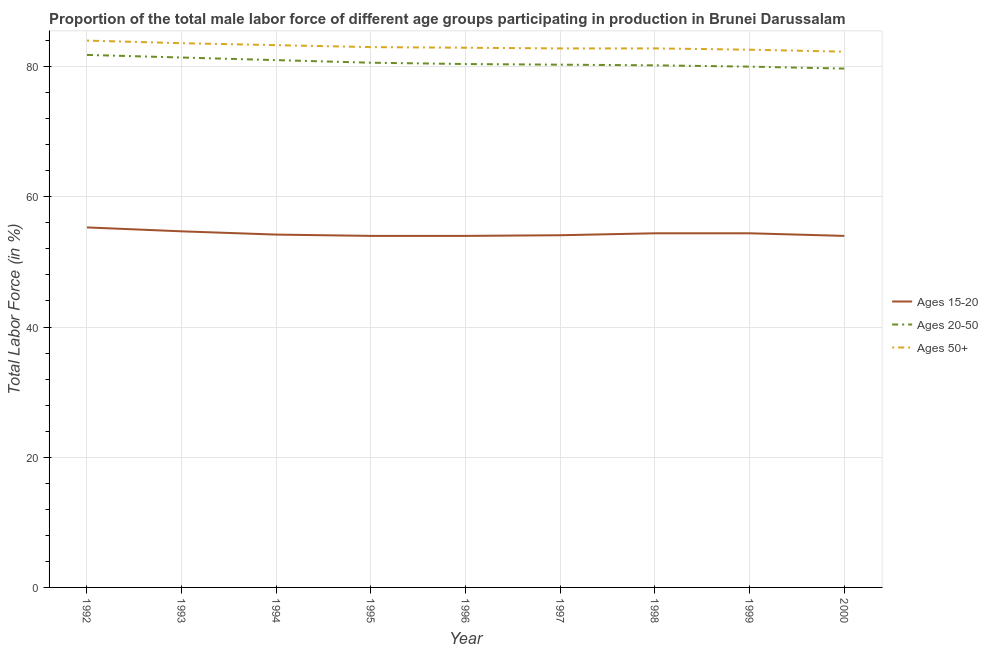Is the number of lines equal to the number of legend labels?
Offer a very short reply. Yes. Across all years, what is the maximum percentage of male labor force within the age group 20-50?
Provide a short and direct response. 81.8. Across all years, what is the minimum percentage of male labor force above age 50?
Your response must be concise. 82.3. In which year was the percentage of male labor force within the age group 15-20 maximum?
Provide a succinct answer. 1992. In which year was the percentage of male labor force within the age group 15-20 minimum?
Make the answer very short. 1995. What is the total percentage of male labor force within the age group 15-20 in the graph?
Ensure brevity in your answer.  489.1. What is the difference between the percentage of male labor force above age 50 in 1995 and that in 2000?
Ensure brevity in your answer.  0.7. What is the difference between the percentage of male labor force above age 50 in 1992 and the percentage of male labor force within the age group 15-20 in 1993?
Your answer should be compact. 29.3. What is the average percentage of male labor force above age 50 per year?
Your answer should be very brief. 83.03. In the year 2000, what is the difference between the percentage of male labor force above age 50 and percentage of male labor force within the age group 15-20?
Ensure brevity in your answer.  28.3. What is the ratio of the percentage of male labor force within the age group 20-50 in 1994 to that in 2000?
Make the answer very short. 1.02. What is the difference between the highest and the second highest percentage of male labor force above age 50?
Give a very brief answer. 0.4. What is the difference between the highest and the lowest percentage of male labor force within the age group 15-20?
Your answer should be very brief. 1.3. In how many years, is the percentage of male labor force above age 50 greater than the average percentage of male labor force above age 50 taken over all years?
Provide a short and direct response. 3. Is the sum of the percentage of male labor force above age 50 in 1998 and 1999 greater than the maximum percentage of male labor force within the age group 15-20 across all years?
Provide a succinct answer. Yes. Is it the case that in every year, the sum of the percentage of male labor force within the age group 15-20 and percentage of male labor force within the age group 20-50 is greater than the percentage of male labor force above age 50?
Make the answer very short. Yes. How many lines are there?
Your answer should be very brief. 3. How many years are there in the graph?
Give a very brief answer. 9. What is the difference between two consecutive major ticks on the Y-axis?
Your answer should be compact. 20. Are the values on the major ticks of Y-axis written in scientific E-notation?
Keep it short and to the point. No. Does the graph contain any zero values?
Provide a short and direct response. No. How many legend labels are there?
Offer a very short reply. 3. How are the legend labels stacked?
Ensure brevity in your answer.  Vertical. What is the title of the graph?
Offer a very short reply. Proportion of the total male labor force of different age groups participating in production in Brunei Darussalam. Does "Transport services" appear as one of the legend labels in the graph?
Provide a succinct answer. No. What is the label or title of the X-axis?
Provide a succinct answer. Year. What is the Total Labor Force (in %) in Ages 15-20 in 1992?
Your response must be concise. 55.3. What is the Total Labor Force (in %) in Ages 20-50 in 1992?
Offer a very short reply. 81.8. What is the Total Labor Force (in %) of Ages 15-20 in 1993?
Provide a short and direct response. 54.7. What is the Total Labor Force (in %) in Ages 20-50 in 1993?
Ensure brevity in your answer.  81.4. What is the Total Labor Force (in %) of Ages 50+ in 1993?
Provide a succinct answer. 83.6. What is the Total Labor Force (in %) of Ages 15-20 in 1994?
Your response must be concise. 54.2. What is the Total Labor Force (in %) of Ages 20-50 in 1994?
Provide a short and direct response. 81. What is the Total Labor Force (in %) in Ages 50+ in 1994?
Provide a succinct answer. 83.3. What is the Total Labor Force (in %) in Ages 20-50 in 1995?
Provide a short and direct response. 80.6. What is the Total Labor Force (in %) of Ages 20-50 in 1996?
Your answer should be compact. 80.4. What is the Total Labor Force (in %) of Ages 50+ in 1996?
Offer a very short reply. 82.9. What is the Total Labor Force (in %) in Ages 15-20 in 1997?
Keep it short and to the point. 54.1. What is the Total Labor Force (in %) of Ages 20-50 in 1997?
Offer a terse response. 80.3. What is the Total Labor Force (in %) of Ages 50+ in 1997?
Offer a very short reply. 82.8. What is the Total Labor Force (in %) of Ages 15-20 in 1998?
Make the answer very short. 54.4. What is the Total Labor Force (in %) of Ages 20-50 in 1998?
Ensure brevity in your answer.  80.2. What is the Total Labor Force (in %) in Ages 50+ in 1998?
Your answer should be very brief. 82.8. What is the Total Labor Force (in %) of Ages 15-20 in 1999?
Keep it short and to the point. 54.4. What is the Total Labor Force (in %) in Ages 20-50 in 1999?
Provide a short and direct response. 80. What is the Total Labor Force (in %) of Ages 50+ in 1999?
Your answer should be very brief. 82.6. What is the Total Labor Force (in %) in Ages 15-20 in 2000?
Provide a succinct answer. 54. What is the Total Labor Force (in %) in Ages 20-50 in 2000?
Offer a terse response. 79.7. What is the Total Labor Force (in %) of Ages 50+ in 2000?
Ensure brevity in your answer.  82.3. Across all years, what is the maximum Total Labor Force (in %) of Ages 15-20?
Give a very brief answer. 55.3. Across all years, what is the maximum Total Labor Force (in %) in Ages 20-50?
Your response must be concise. 81.8. Across all years, what is the minimum Total Labor Force (in %) of Ages 20-50?
Make the answer very short. 79.7. Across all years, what is the minimum Total Labor Force (in %) of Ages 50+?
Keep it short and to the point. 82.3. What is the total Total Labor Force (in %) in Ages 15-20 in the graph?
Offer a terse response. 489.1. What is the total Total Labor Force (in %) in Ages 20-50 in the graph?
Your answer should be very brief. 725.4. What is the total Total Labor Force (in %) of Ages 50+ in the graph?
Ensure brevity in your answer.  747.3. What is the difference between the Total Labor Force (in %) in Ages 15-20 in 1992 and that in 1994?
Offer a very short reply. 1.1. What is the difference between the Total Labor Force (in %) of Ages 20-50 in 1992 and that in 1994?
Your response must be concise. 0.8. What is the difference between the Total Labor Force (in %) in Ages 50+ in 1992 and that in 1995?
Provide a succinct answer. 1. What is the difference between the Total Labor Force (in %) of Ages 15-20 in 1992 and that in 1996?
Provide a succinct answer. 1.3. What is the difference between the Total Labor Force (in %) in Ages 50+ in 1992 and that in 1996?
Provide a succinct answer. 1.1. What is the difference between the Total Labor Force (in %) in Ages 15-20 in 1992 and that in 1997?
Provide a succinct answer. 1.2. What is the difference between the Total Labor Force (in %) of Ages 20-50 in 1992 and that in 1997?
Your answer should be very brief. 1.5. What is the difference between the Total Labor Force (in %) of Ages 50+ in 1992 and that in 1997?
Make the answer very short. 1.2. What is the difference between the Total Labor Force (in %) in Ages 20-50 in 1993 and that in 1994?
Your answer should be compact. 0.4. What is the difference between the Total Labor Force (in %) of Ages 50+ in 1993 and that in 1994?
Provide a succinct answer. 0.3. What is the difference between the Total Labor Force (in %) of Ages 15-20 in 1993 and that in 1995?
Your response must be concise. 0.7. What is the difference between the Total Labor Force (in %) of Ages 20-50 in 1993 and that in 1995?
Your answer should be very brief. 0.8. What is the difference between the Total Labor Force (in %) in Ages 15-20 in 1993 and that in 1996?
Provide a succinct answer. 0.7. What is the difference between the Total Labor Force (in %) in Ages 15-20 in 1993 and that in 1997?
Your response must be concise. 0.6. What is the difference between the Total Labor Force (in %) of Ages 15-20 in 1993 and that in 1998?
Keep it short and to the point. 0.3. What is the difference between the Total Labor Force (in %) of Ages 20-50 in 1993 and that in 1998?
Keep it short and to the point. 1.2. What is the difference between the Total Labor Force (in %) in Ages 50+ in 1993 and that in 1998?
Your answer should be very brief. 0.8. What is the difference between the Total Labor Force (in %) in Ages 50+ in 1993 and that in 1999?
Provide a short and direct response. 1. What is the difference between the Total Labor Force (in %) of Ages 15-20 in 1993 and that in 2000?
Keep it short and to the point. 0.7. What is the difference between the Total Labor Force (in %) in Ages 20-50 in 1993 and that in 2000?
Make the answer very short. 1.7. What is the difference between the Total Labor Force (in %) in Ages 15-20 in 1994 and that in 1995?
Provide a succinct answer. 0.2. What is the difference between the Total Labor Force (in %) of Ages 15-20 in 1994 and that in 1996?
Your response must be concise. 0.2. What is the difference between the Total Labor Force (in %) of Ages 50+ in 1994 and that in 1996?
Make the answer very short. 0.4. What is the difference between the Total Labor Force (in %) of Ages 20-50 in 1994 and that in 1997?
Offer a very short reply. 0.7. What is the difference between the Total Labor Force (in %) of Ages 50+ in 1994 and that in 1998?
Make the answer very short. 0.5. What is the difference between the Total Labor Force (in %) of Ages 15-20 in 1994 and that in 1999?
Your answer should be compact. -0.2. What is the difference between the Total Labor Force (in %) of Ages 20-50 in 1994 and that in 1999?
Your answer should be compact. 1. What is the difference between the Total Labor Force (in %) in Ages 20-50 in 1994 and that in 2000?
Offer a terse response. 1.3. What is the difference between the Total Labor Force (in %) in Ages 20-50 in 1995 and that in 1996?
Make the answer very short. 0.2. What is the difference between the Total Labor Force (in %) of Ages 50+ in 1995 and that in 1996?
Offer a very short reply. 0.1. What is the difference between the Total Labor Force (in %) of Ages 50+ in 1995 and that in 1997?
Give a very brief answer. 0.2. What is the difference between the Total Labor Force (in %) of Ages 15-20 in 1995 and that in 1998?
Give a very brief answer. -0.4. What is the difference between the Total Labor Force (in %) of Ages 50+ in 1995 and that in 1998?
Make the answer very short. 0.2. What is the difference between the Total Labor Force (in %) in Ages 50+ in 1995 and that in 1999?
Your answer should be compact. 0.4. What is the difference between the Total Labor Force (in %) of Ages 15-20 in 1995 and that in 2000?
Provide a short and direct response. 0. What is the difference between the Total Labor Force (in %) in Ages 20-50 in 1995 and that in 2000?
Your answer should be compact. 0.9. What is the difference between the Total Labor Force (in %) in Ages 50+ in 1995 and that in 2000?
Make the answer very short. 0.7. What is the difference between the Total Labor Force (in %) of Ages 20-50 in 1996 and that in 1998?
Offer a very short reply. 0.2. What is the difference between the Total Labor Force (in %) in Ages 50+ in 1996 and that in 1998?
Provide a succinct answer. 0.1. What is the difference between the Total Labor Force (in %) of Ages 15-20 in 1996 and that in 2000?
Your answer should be very brief. 0. What is the difference between the Total Labor Force (in %) in Ages 20-50 in 1996 and that in 2000?
Provide a succinct answer. 0.7. What is the difference between the Total Labor Force (in %) in Ages 50+ in 1997 and that in 1998?
Give a very brief answer. 0. What is the difference between the Total Labor Force (in %) in Ages 50+ in 1997 and that in 1999?
Provide a short and direct response. 0.2. What is the difference between the Total Labor Force (in %) of Ages 50+ in 1997 and that in 2000?
Offer a terse response. 0.5. What is the difference between the Total Labor Force (in %) of Ages 15-20 in 1998 and that in 2000?
Offer a very short reply. 0.4. What is the difference between the Total Labor Force (in %) of Ages 50+ in 1998 and that in 2000?
Your answer should be very brief. 0.5. What is the difference between the Total Labor Force (in %) in Ages 15-20 in 1999 and that in 2000?
Offer a very short reply. 0.4. What is the difference between the Total Labor Force (in %) of Ages 20-50 in 1999 and that in 2000?
Your response must be concise. 0.3. What is the difference between the Total Labor Force (in %) of Ages 15-20 in 1992 and the Total Labor Force (in %) of Ages 20-50 in 1993?
Provide a succinct answer. -26.1. What is the difference between the Total Labor Force (in %) of Ages 15-20 in 1992 and the Total Labor Force (in %) of Ages 50+ in 1993?
Ensure brevity in your answer.  -28.3. What is the difference between the Total Labor Force (in %) in Ages 20-50 in 1992 and the Total Labor Force (in %) in Ages 50+ in 1993?
Make the answer very short. -1.8. What is the difference between the Total Labor Force (in %) in Ages 15-20 in 1992 and the Total Labor Force (in %) in Ages 20-50 in 1994?
Provide a succinct answer. -25.7. What is the difference between the Total Labor Force (in %) of Ages 15-20 in 1992 and the Total Labor Force (in %) of Ages 20-50 in 1995?
Your answer should be compact. -25.3. What is the difference between the Total Labor Force (in %) of Ages 15-20 in 1992 and the Total Labor Force (in %) of Ages 50+ in 1995?
Make the answer very short. -27.7. What is the difference between the Total Labor Force (in %) of Ages 20-50 in 1992 and the Total Labor Force (in %) of Ages 50+ in 1995?
Make the answer very short. -1.2. What is the difference between the Total Labor Force (in %) in Ages 15-20 in 1992 and the Total Labor Force (in %) in Ages 20-50 in 1996?
Give a very brief answer. -25.1. What is the difference between the Total Labor Force (in %) in Ages 15-20 in 1992 and the Total Labor Force (in %) in Ages 50+ in 1996?
Keep it short and to the point. -27.6. What is the difference between the Total Labor Force (in %) of Ages 20-50 in 1992 and the Total Labor Force (in %) of Ages 50+ in 1996?
Give a very brief answer. -1.1. What is the difference between the Total Labor Force (in %) of Ages 15-20 in 1992 and the Total Labor Force (in %) of Ages 50+ in 1997?
Ensure brevity in your answer.  -27.5. What is the difference between the Total Labor Force (in %) in Ages 20-50 in 1992 and the Total Labor Force (in %) in Ages 50+ in 1997?
Make the answer very short. -1. What is the difference between the Total Labor Force (in %) of Ages 15-20 in 1992 and the Total Labor Force (in %) of Ages 20-50 in 1998?
Your response must be concise. -24.9. What is the difference between the Total Labor Force (in %) of Ages 15-20 in 1992 and the Total Labor Force (in %) of Ages 50+ in 1998?
Offer a very short reply. -27.5. What is the difference between the Total Labor Force (in %) in Ages 20-50 in 1992 and the Total Labor Force (in %) in Ages 50+ in 1998?
Make the answer very short. -1. What is the difference between the Total Labor Force (in %) of Ages 15-20 in 1992 and the Total Labor Force (in %) of Ages 20-50 in 1999?
Your response must be concise. -24.7. What is the difference between the Total Labor Force (in %) in Ages 15-20 in 1992 and the Total Labor Force (in %) in Ages 50+ in 1999?
Provide a short and direct response. -27.3. What is the difference between the Total Labor Force (in %) in Ages 15-20 in 1992 and the Total Labor Force (in %) in Ages 20-50 in 2000?
Give a very brief answer. -24.4. What is the difference between the Total Labor Force (in %) in Ages 15-20 in 1992 and the Total Labor Force (in %) in Ages 50+ in 2000?
Make the answer very short. -27. What is the difference between the Total Labor Force (in %) of Ages 20-50 in 1992 and the Total Labor Force (in %) of Ages 50+ in 2000?
Give a very brief answer. -0.5. What is the difference between the Total Labor Force (in %) in Ages 15-20 in 1993 and the Total Labor Force (in %) in Ages 20-50 in 1994?
Your answer should be very brief. -26.3. What is the difference between the Total Labor Force (in %) of Ages 15-20 in 1993 and the Total Labor Force (in %) of Ages 50+ in 1994?
Provide a succinct answer. -28.6. What is the difference between the Total Labor Force (in %) in Ages 15-20 in 1993 and the Total Labor Force (in %) in Ages 20-50 in 1995?
Your response must be concise. -25.9. What is the difference between the Total Labor Force (in %) in Ages 15-20 in 1993 and the Total Labor Force (in %) in Ages 50+ in 1995?
Give a very brief answer. -28.3. What is the difference between the Total Labor Force (in %) of Ages 15-20 in 1993 and the Total Labor Force (in %) of Ages 20-50 in 1996?
Your answer should be compact. -25.7. What is the difference between the Total Labor Force (in %) in Ages 15-20 in 1993 and the Total Labor Force (in %) in Ages 50+ in 1996?
Your answer should be compact. -28.2. What is the difference between the Total Labor Force (in %) in Ages 20-50 in 1993 and the Total Labor Force (in %) in Ages 50+ in 1996?
Keep it short and to the point. -1.5. What is the difference between the Total Labor Force (in %) in Ages 15-20 in 1993 and the Total Labor Force (in %) in Ages 20-50 in 1997?
Your answer should be very brief. -25.6. What is the difference between the Total Labor Force (in %) in Ages 15-20 in 1993 and the Total Labor Force (in %) in Ages 50+ in 1997?
Your answer should be very brief. -28.1. What is the difference between the Total Labor Force (in %) of Ages 20-50 in 1993 and the Total Labor Force (in %) of Ages 50+ in 1997?
Your response must be concise. -1.4. What is the difference between the Total Labor Force (in %) of Ages 15-20 in 1993 and the Total Labor Force (in %) of Ages 20-50 in 1998?
Your answer should be compact. -25.5. What is the difference between the Total Labor Force (in %) of Ages 15-20 in 1993 and the Total Labor Force (in %) of Ages 50+ in 1998?
Make the answer very short. -28.1. What is the difference between the Total Labor Force (in %) of Ages 15-20 in 1993 and the Total Labor Force (in %) of Ages 20-50 in 1999?
Offer a terse response. -25.3. What is the difference between the Total Labor Force (in %) in Ages 15-20 in 1993 and the Total Labor Force (in %) in Ages 50+ in 1999?
Give a very brief answer. -27.9. What is the difference between the Total Labor Force (in %) in Ages 20-50 in 1993 and the Total Labor Force (in %) in Ages 50+ in 1999?
Your answer should be compact. -1.2. What is the difference between the Total Labor Force (in %) in Ages 15-20 in 1993 and the Total Labor Force (in %) in Ages 20-50 in 2000?
Give a very brief answer. -25. What is the difference between the Total Labor Force (in %) of Ages 15-20 in 1993 and the Total Labor Force (in %) of Ages 50+ in 2000?
Provide a succinct answer. -27.6. What is the difference between the Total Labor Force (in %) of Ages 20-50 in 1993 and the Total Labor Force (in %) of Ages 50+ in 2000?
Offer a very short reply. -0.9. What is the difference between the Total Labor Force (in %) in Ages 15-20 in 1994 and the Total Labor Force (in %) in Ages 20-50 in 1995?
Your answer should be very brief. -26.4. What is the difference between the Total Labor Force (in %) in Ages 15-20 in 1994 and the Total Labor Force (in %) in Ages 50+ in 1995?
Your answer should be compact. -28.8. What is the difference between the Total Labor Force (in %) of Ages 15-20 in 1994 and the Total Labor Force (in %) of Ages 20-50 in 1996?
Your answer should be very brief. -26.2. What is the difference between the Total Labor Force (in %) of Ages 15-20 in 1994 and the Total Labor Force (in %) of Ages 50+ in 1996?
Make the answer very short. -28.7. What is the difference between the Total Labor Force (in %) in Ages 15-20 in 1994 and the Total Labor Force (in %) in Ages 20-50 in 1997?
Offer a very short reply. -26.1. What is the difference between the Total Labor Force (in %) in Ages 15-20 in 1994 and the Total Labor Force (in %) in Ages 50+ in 1997?
Offer a very short reply. -28.6. What is the difference between the Total Labor Force (in %) in Ages 15-20 in 1994 and the Total Labor Force (in %) in Ages 20-50 in 1998?
Keep it short and to the point. -26. What is the difference between the Total Labor Force (in %) of Ages 15-20 in 1994 and the Total Labor Force (in %) of Ages 50+ in 1998?
Your answer should be compact. -28.6. What is the difference between the Total Labor Force (in %) in Ages 15-20 in 1994 and the Total Labor Force (in %) in Ages 20-50 in 1999?
Your answer should be very brief. -25.8. What is the difference between the Total Labor Force (in %) in Ages 15-20 in 1994 and the Total Labor Force (in %) in Ages 50+ in 1999?
Keep it short and to the point. -28.4. What is the difference between the Total Labor Force (in %) in Ages 15-20 in 1994 and the Total Labor Force (in %) in Ages 20-50 in 2000?
Make the answer very short. -25.5. What is the difference between the Total Labor Force (in %) in Ages 15-20 in 1994 and the Total Labor Force (in %) in Ages 50+ in 2000?
Provide a succinct answer. -28.1. What is the difference between the Total Labor Force (in %) of Ages 20-50 in 1994 and the Total Labor Force (in %) of Ages 50+ in 2000?
Give a very brief answer. -1.3. What is the difference between the Total Labor Force (in %) of Ages 15-20 in 1995 and the Total Labor Force (in %) of Ages 20-50 in 1996?
Your answer should be compact. -26.4. What is the difference between the Total Labor Force (in %) of Ages 15-20 in 1995 and the Total Labor Force (in %) of Ages 50+ in 1996?
Your answer should be compact. -28.9. What is the difference between the Total Labor Force (in %) in Ages 15-20 in 1995 and the Total Labor Force (in %) in Ages 20-50 in 1997?
Provide a short and direct response. -26.3. What is the difference between the Total Labor Force (in %) of Ages 15-20 in 1995 and the Total Labor Force (in %) of Ages 50+ in 1997?
Give a very brief answer. -28.8. What is the difference between the Total Labor Force (in %) in Ages 20-50 in 1995 and the Total Labor Force (in %) in Ages 50+ in 1997?
Ensure brevity in your answer.  -2.2. What is the difference between the Total Labor Force (in %) in Ages 15-20 in 1995 and the Total Labor Force (in %) in Ages 20-50 in 1998?
Provide a succinct answer. -26.2. What is the difference between the Total Labor Force (in %) in Ages 15-20 in 1995 and the Total Labor Force (in %) in Ages 50+ in 1998?
Offer a terse response. -28.8. What is the difference between the Total Labor Force (in %) of Ages 20-50 in 1995 and the Total Labor Force (in %) of Ages 50+ in 1998?
Ensure brevity in your answer.  -2.2. What is the difference between the Total Labor Force (in %) in Ages 15-20 in 1995 and the Total Labor Force (in %) in Ages 20-50 in 1999?
Offer a terse response. -26. What is the difference between the Total Labor Force (in %) of Ages 15-20 in 1995 and the Total Labor Force (in %) of Ages 50+ in 1999?
Your answer should be compact. -28.6. What is the difference between the Total Labor Force (in %) in Ages 15-20 in 1995 and the Total Labor Force (in %) in Ages 20-50 in 2000?
Provide a succinct answer. -25.7. What is the difference between the Total Labor Force (in %) of Ages 15-20 in 1995 and the Total Labor Force (in %) of Ages 50+ in 2000?
Offer a terse response. -28.3. What is the difference between the Total Labor Force (in %) in Ages 15-20 in 1996 and the Total Labor Force (in %) in Ages 20-50 in 1997?
Your response must be concise. -26.3. What is the difference between the Total Labor Force (in %) in Ages 15-20 in 1996 and the Total Labor Force (in %) in Ages 50+ in 1997?
Offer a very short reply. -28.8. What is the difference between the Total Labor Force (in %) of Ages 15-20 in 1996 and the Total Labor Force (in %) of Ages 20-50 in 1998?
Give a very brief answer. -26.2. What is the difference between the Total Labor Force (in %) in Ages 15-20 in 1996 and the Total Labor Force (in %) in Ages 50+ in 1998?
Provide a succinct answer. -28.8. What is the difference between the Total Labor Force (in %) in Ages 15-20 in 1996 and the Total Labor Force (in %) in Ages 20-50 in 1999?
Your answer should be compact. -26. What is the difference between the Total Labor Force (in %) of Ages 15-20 in 1996 and the Total Labor Force (in %) of Ages 50+ in 1999?
Make the answer very short. -28.6. What is the difference between the Total Labor Force (in %) in Ages 20-50 in 1996 and the Total Labor Force (in %) in Ages 50+ in 1999?
Offer a terse response. -2.2. What is the difference between the Total Labor Force (in %) of Ages 15-20 in 1996 and the Total Labor Force (in %) of Ages 20-50 in 2000?
Offer a terse response. -25.7. What is the difference between the Total Labor Force (in %) in Ages 15-20 in 1996 and the Total Labor Force (in %) in Ages 50+ in 2000?
Offer a terse response. -28.3. What is the difference between the Total Labor Force (in %) in Ages 20-50 in 1996 and the Total Labor Force (in %) in Ages 50+ in 2000?
Offer a terse response. -1.9. What is the difference between the Total Labor Force (in %) of Ages 15-20 in 1997 and the Total Labor Force (in %) of Ages 20-50 in 1998?
Make the answer very short. -26.1. What is the difference between the Total Labor Force (in %) in Ages 15-20 in 1997 and the Total Labor Force (in %) in Ages 50+ in 1998?
Give a very brief answer. -28.7. What is the difference between the Total Labor Force (in %) of Ages 15-20 in 1997 and the Total Labor Force (in %) of Ages 20-50 in 1999?
Your answer should be compact. -25.9. What is the difference between the Total Labor Force (in %) of Ages 15-20 in 1997 and the Total Labor Force (in %) of Ages 50+ in 1999?
Keep it short and to the point. -28.5. What is the difference between the Total Labor Force (in %) of Ages 15-20 in 1997 and the Total Labor Force (in %) of Ages 20-50 in 2000?
Your answer should be compact. -25.6. What is the difference between the Total Labor Force (in %) in Ages 15-20 in 1997 and the Total Labor Force (in %) in Ages 50+ in 2000?
Offer a terse response. -28.2. What is the difference between the Total Labor Force (in %) in Ages 15-20 in 1998 and the Total Labor Force (in %) in Ages 20-50 in 1999?
Offer a terse response. -25.6. What is the difference between the Total Labor Force (in %) of Ages 15-20 in 1998 and the Total Labor Force (in %) of Ages 50+ in 1999?
Your answer should be compact. -28.2. What is the difference between the Total Labor Force (in %) in Ages 20-50 in 1998 and the Total Labor Force (in %) in Ages 50+ in 1999?
Your answer should be compact. -2.4. What is the difference between the Total Labor Force (in %) in Ages 15-20 in 1998 and the Total Labor Force (in %) in Ages 20-50 in 2000?
Make the answer very short. -25.3. What is the difference between the Total Labor Force (in %) of Ages 15-20 in 1998 and the Total Labor Force (in %) of Ages 50+ in 2000?
Give a very brief answer. -27.9. What is the difference between the Total Labor Force (in %) in Ages 15-20 in 1999 and the Total Labor Force (in %) in Ages 20-50 in 2000?
Your answer should be very brief. -25.3. What is the difference between the Total Labor Force (in %) of Ages 15-20 in 1999 and the Total Labor Force (in %) of Ages 50+ in 2000?
Provide a succinct answer. -27.9. What is the difference between the Total Labor Force (in %) of Ages 20-50 in 1999 and the Total Labor Force (in %) of Ages 50+ in 2000?
Your response must be concise. -2.3. What is the average Total Labor Force (in %) in Ages 15-20 per year?
Make the answer very short. 54.34. What is the average Total Labor Force (in %) in Ages 20-50 per year?
Your response must be concise. 80.6. What is the average Total Labor Force (in %) of Ages 50+ per year?
Give a very brief answer. 83.03. In the year 1992, what is the difference between the Total Labor Force (in %) of Ages 15-20 and Total Labor Force (in %) of Ages 20-50?
Your response must be concise. -26.5. In the year 1992, what is the difference between the Total Labor Force (in %) in Ages 15-20 and Total Labor Force (in %) in Ages 50+?
Provide a succinct answer. -28.7. In the year 1993, what is the difference between the Total Labor Force (in %) of Ages 15-20 and Total Labor Force (in %) of Ages 20-50?
Keep it short and to the point. -26.7. In the year 1993, what is the difference between the Total Labor Force (in %) of Ages 15-20 and Total Labor Force (in %) of Ages 50+?
Ensure brevity in your answer.  -28.9. In the year 1994, what is the difference between the Total Labor Force (in %) in Ages 15-20 and Total Labor Force (in %) in Ages 20-50?
Offer a very short reply. -26.8. In the year 1994, what is the difference between the Total Labor Force (in %) of Ages 15-20 and Total Labor Force (in %) of Ages 50+?
Offer a very short reply. -29.1. In the year 1995, what is the difference between the Total Labor Force (in %) in Ages 15-20 and Total Labor Force (in %) in Ages 20-50?
Keep it short and to the point. -26.6. In the year 1995, what is the difference between the Total Labor Force (in %) in Ages 15-20 and Total Labor Force (in %) in Ages 50+?
Give a very brief answer. -29. In the year 1996, what is the difference between the Total Labor Force (in %) of Ages 15-20 and Total Labor Force (in %) of Ages 20-50?
Make the answer very short. -26.4. In the year 1996, what is the difference between the Total Labor Force (in %) of Ages 15-20 and Total Labor Force (in %) of Ages 50+?
Your answer should be compact. -28.9. In the year 1997, what is the difference between the Total Labor Force (in %) of Ages 15-20 and Total Labor Force (in %) of Ages 20-50?
Offer a terse response. -26.2. In the year 1997, what is the difference between the Total Labor Force (in %) in Ages 15-20 and Total Labor Force (in %) in Ages 50+?
Your response must be concise. -28.7. In the year 1997, what is the difference between the Total Labor Force (in %) in Ages 20-50 and Total Labor Force (in %) in Ages 50+?
Ensure brevity in your answer.  -2.5. In the year 1998, what is the difference between the Total Labor Force (in %) of Ages 15-20 and Total Labor Force (in %) of Ages 20-50?
Give a very brief answer. -25.8. In the year 1998, what is the difference between the Total Labor Force (in %) in Ages 15-20 and Total Labor Force (in %) in Ages 50+?
Your response must be concise. -28.4. In the year 1998, what is the difference between the Total Labor Force (in %) in Ages 20-50 and Total Labor Force (in %) in Ages 50+?
Provide a short and direct response. -2.6. In the year 1999, what is the difference between the Total Labor Force (in %) of Ages 15-20 and Total Labor Force (in %) of Ages 20-50?
Offer a terse response. -25.6. In the year 1999, what is the difference between the Total Labor Force (in %) of Ages 15-20 and Total Labor Force (in %) of Ages 50+?
Give a very brief answer. -28.2. In the year 2000, what is the difference between the Total Labor Force (in %) in Ages 15-20 and Total Labor Force (in %) in Ages 20-50?
Your response must be concise. -25.7. In the year 2000, what is the difference between the Total Labor Force (in %) of Ages 15-20 and Total Labor Force (in %) of Ages 50+?
Offer a terse response. -28.3. What is the ratio of the Total Labor Force (in %) of Ages 15-20 in 1992 to that in 1994?
Your answer should be compact. 1.02. What is the ratio of the Total Labor Force (in %) in Ages 20-50 in 1992 to that in 1994?
Offer a very short reply. 1.01. What is the ratio of the Total Labor Force (in %) in Ages 50+ in 1992 to that in 1994?
Make the answer very short. 1.01. What is the ratio of the Total Labor Force (in %) in Ages 15-20 in 1992 to that in 1995?
Your answer should be very brief. 1.02. What is the ratio of the Total Labor Force (in %) of Ages 20-50 in 1992 to that in 1995?
Your answer should be very brief. 1.01. What is the ratio of the Total Labor Force (in %) of Ages 50+ in 1992 to that in 1995?
Provide a short and direct response. 1.01. What is the ratio of the Total Labor Force (in %) in Ages 15-20 in 1992 to that in 1996?
Provide a succinct answer. 1.02. What is the ratio of the Total Labor Force (in %) in Ages 20-50 in 1992 to that in 1996?
Your answer should be very brief. 1.02. What is the ratio of the Total Labor Force (in %) in Ages 50+ in 1992 to that in 1996?
Offer a very short reply. 1.01. What is the ratio of the Total Labor Force (in %) in Ages 15-20 in 1992 to that in 1997?
Make the answer very short. 1.02. What is the ratio of the Total Labor Force (in %) of Ages 20-50 in 1992 to that in 1997?
Ensure brevity in your answer.  1.02. What is the ratio of the Total Labor Force (in %) of Ages 50+ in 1992 to that in 1997?
Give a very brief answer. 1.01. What is the ratio of the Total Labor Force (in %) in Ages 15-20 in 1992 to that in 1998?
Provide a succinct answer. 1.02. What is the ratio of the Total Labor Force (in %) of Ages 50+ in 1992 to that in 1998?
Give a very brief answer. 1.01. What is the ratio of the Total Labor Force (in %) of Ages 15-20 in 1992 to that in 1999?
Your answer should be compact. 1.02. What is the ratio of the Total Labor Force (in %) of Ages 20-50 in 1992 to that in 1999?
Your response must be concise. 1.02. What is the ratio of the Total Labor Force (in %) of Ages 50+ in 1992 to that in 1999?
Keep it short and to the point. 1.02. What is the ratio of the Total Labor Force (in %) in Ages 15-20 in 1992 to that in 2000?
Your answer should be compact. 1.02. What is the ratio of the Total Labor Force (in %) in Ages 20-50 in 1992 to that in 2000?
Make the answer very short. 1.03. What is the ratio of the Total Labor Force (in %) of Ages 50+ in 1992 to that in 2000?
Make the answer very short. 1.02. What is the ratio of the Total Labor Force (in %) of Ages 15-20 in 1993 to that in 1994?
Give a very brief answer. 1.01. What is the ratio of the Total Labor Force (in %) of Ages 20-50 in 1993 to that in 1994?
Your answer should be very brief. 1. What is the ratio of the Total Labor Force (in %) of Ages 50+ in 1993 to that in 1994?
Your response must be concise. 1. What is the ratio of the Total Labor Force (in %) of Ages 20-50 in 1993 to that in 1995?
Your answer should be compact. 1.01. What is the ratio of the Total Labor Force (in %) in Ages 50+ in 1993 to that in 1995?
Your answer should be compact. 1.01. What is the ratio of the Total Labor Force (in %) of Ages 15-20 in 1993 to that in 1996?
Your answer should be compact. 1.01. What is the ratio of the Total Labor Force (in %) of Ages 20-50 in 1993 to that in 1996?
Provide a succinct answer. 1.01. What is the ratio of the Total Labor Force (in %) in Ages 50+ in 1993 to that in 1996?
Ensure brevity in your answer.  1.01. What is the ratio of the Total Labor Force (in %) in Ages 15-20 in 1993 to that in 1997?
Your answer should be very brief. 1.01. What is the ratio of the Total Labor Force (in %) in Ages 20-50 in 1993 to that in 1997?
Provide a succinct answer. 1.01. What is the ratio of the Total Labor Force (in %) of Ages 50+ in 1993 to that in 1997?
Your answer should be very brief. 1.01. What is the ratio of the Total Labor Force (in %) in Ages 50+ in 1993 to that in 1998?
Give a very brief answer. 1.01. What is the ratio of the Total Labor Force (in %) of Ages 15-20 in 1993 to that in 1999?
Provide a short and direct response. 1.01. What is the ratio of the Total Labor Force (in %) of Ages 20-50 in 1993 to that in 1999?
Your response must be concise. 1.02. What is the ratio of the Total Labor Force (in %) in Ages 50+ in 1993 to that in 1999?
Ensure brevity in your answer.  1.01. What is the ratio of the Total Labor Force (in %) of Ages 20-50 in 1993 to that in 2000?
Offer a very short reply. 1.02. What is the ratio of the Total Labor Force (in %) of Ages 50+ in 1993 to that in 2000?
Your answer should be compact. 1.02. What is the ratio of the Total Labor Force (in %) in Ages 20-50 in 1994 to that in 1995?
Make the answer very short. 1. What is the ratio of the Total Labor Force (in %) in Ages 20-50 in 1994 to that in 1996?
Your answer should be compact. 1.01. What is the ratio of the Total Labor Force (in %) of Ages 20-50 in 1994 to that in 1997?
Your response must be concise. 1.01. What is the ratio of the Total Labor Force (in %) in Ages 15-20 in 1994 to that in 1998?
Provide a short and direct response. 1. What is the ratio of the Total Labor Force (in %) of Ages 20-50 in 1994 to that in 1999?
Ensure brevity in your answer.  1.01. What is the ratio of the Total Labor Force (in %) of Ages 50+ in 1994 to that in 1999?
Provide a short and direct response. 1.01. What is the ratio of the Total Labor Force (in %) in Ages 20-50 in 1994 to that in 2000?
Your answer should be very brief. 1.02. What is the ratio of the Total Labor Force (in %) in Ages 50+ in 1994 to that in 2000?
Offer a terse response. 1.01. What is the ratio of the Total Labor Force (in %) of Ages 20-50 in 1995 to that in 1996?
Your answer should be compact. 1. What is the ratio of the Total Labor Force (in %) in Ages 50+ in 1995 to that in 1996?
Provide a short and direct response. 1. What is the ratio of the Total Labor Force (in %) in Ages 15-20 in 1995 to that in 1997?
Your response must be concise. 1. What is the ratio of the Total Labor Force (in %) of Ages 50+ in 1995 to that in 1997?
Ensure brevity in your answer.  1. What is the ratio of the Total Labor Force (in %) in Ages 20-50 in 1995 to that in 1998?
Make the answer very short. 1. What is the ratio of the Total Labor Force (in %) of Ages 50+ in 1995 to that in 1998?
Provide a short and direct response. 1. What is the ratio of the Total Labor Force (in %) in Ages 20-50 in 1995 to that in 1999?
Offer a very short reply. 1.01. What is the ratio of the Total Labor Force (in %) in Ages 15-20 in 1995 to that in 2000?
Your answer should be compact. 1. What is the ratio of the Total Labor Force (in %) in Ages 20-50 in 1995 to that in 2000?
Keep it short and to the point. 1.01. What is the ratio of the Total Labor Force (in %) in Ages 50+ in 1995 to that in 2000?
Your response must be concise. 1.01. What is the ratio of the Total Labor Force (in %) in Ages 15-20 in 1996 to that in 1998?
Provide a short and direct response. 0.99. What is the ratio of the Total Labor Force (in %) of Ages 15-20 in 1996 to that in 1999?
Your response must be concise. 0.99. What is the ratio of the Total Labor Force (in %) of Ages 20-50 in 1996 to that in 1999?
Ensure brevity in your answer.  1. What is the ratio of the Total Labor Force (in %) of Ages 50+ in 1996 to that in 1999?
Make the answer very short. 1. What is the ratio of the Total Labor Force (in %) in Ages 20-50 in 1996 to that in 2000?
Ensure brevity in your answer.  1.01. What is the ratio of the Total Labor Force (in %) of Ages 50+ in 1996 to that in 2000?
Make the answer very short. 1.01. What is the ratio of the Total Labor Force (in %) in Ages 20-50 in 1997 to that in 1999?
Your answer should be compact. 1. What is the ratio of the Total Labor Force (in %) of Ages 20-50 in 1997 to that in 2000?
Keep it short and to the point. 1.01. What is the ratio of the Total Labor Force (in %) in Ages 50+ in 1997 to that in 2000?
Offer a terse response. 1.01. What is the ratio of the Total Labor Force (in %) in Ages 20-50 in 1998 to that in 1999?
Ensure brevity in your answer.  1. What is the ratio of the Total Labor Force (in %) in Ages 15-20 in 1998 to that in 2000?
Provide a succinct answer. 1.01. What is the ratio of the Total Labor Force (in %) of Ages 20-50 in 1998 to that in 2000?
Give a very brief answer. 1.01. What is the ratio of the Total Labor Force (in %) of Ages 15-20 in 1999 to that in 2000?
Provide a short and direct response. 1.01. What is the ratio of the Total Labor Force (in %) of Ages 50+ in 1999 to that in 2000?
Your response must be concise. 1. What is the difference between the highest and the second highest Total Labor Force (in %) in Ages 15-20?
Keep it short and to the point. 0.6. What is the difference between the highest and the lowest Total Labor Force (in %) in Ages 20-50?
Offer a terse response. 2.1. What is the difference between the highest and the lowest Total Labor Force (in %) in Ages 50+?
Offer a terse response. 1.7. 